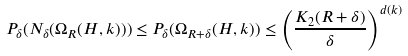Convert formula to latex. <formula><loc_0><loc_0><loc_500><loc_500>P _ { \delta } ( N _ { \delta } ( \Omega _ { R } ( H , k ) ) ) \leq P _ { \delta } ( \Omega _ { R + \delta } ( H , k ) ) \leq \left ( \frac { K _ { 2 } ( R + \delta ) } { \delta } \right ) ^ { d ( k ) }</formula> 